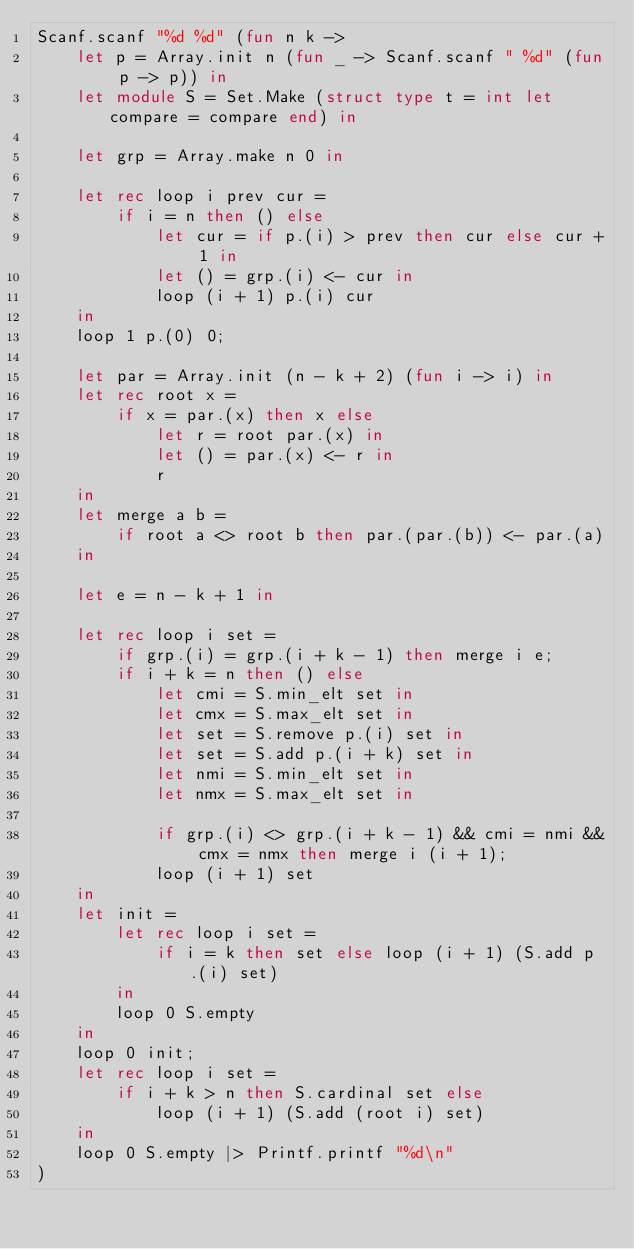Convert code to text. <code><loc_0><loc_0><loc_500><loc_500><_OCaml_>Scanf.scanf "%d %d" (fun n k ->
    let p = Array.init n (fun _ -> Scanf.scanf " %d" (fun p -> p)) in
    let module S = Set.Make (struct type t = int let compare = compare end) in

    let grp = Array.make n 0 in

    let rec loop i prev cur =
        if i = n then () else
            let cur = if p.(i) > prev then cur else cur + 1 in
            let () = grp.(i) <- cur in
            loop (i + 1) p.(i) cur
    in
    loop 1 p.(0) 0;

    let par = Array.init (n - k + 2) (fun i -> i) in
    let rec root x =
        if x = par.(x) then x else
            let r = root par.(x) in
            let () = par.(x) <- r in
            r
    in
    let merge a b =
        if root a <> root b then par.(par.(b)) <- par.(a)
    in

    let e = n - k + 1 in

    let rec loop i set =
        if grp.(i) = grp.(i + k - 1) then merge i e;
        if i + k = n then () else
            let cmi = S.min_elt set in
            let cmx = S.max_elt set in
            let set = S.remove p.(i) set in
            let set = S.add p.(i + k) set in
            let nmi = S.min_elt set in
            let nmx = S.max_elt set in

            if grp.(i) <> grp.(i + k - 1) && cmi = nmi && cmx = nmx then merge i (i + 1);
            loop (i + 1) set
    in
    let init =
        let rec loop i set =
            if i = k then set else loop (i + 1) (S.add p.(i) set)
        in
        loop 0 S.empty
    in
    loop 0 init;
    let rec loop i set =
        if i + k > n then S.cardinal set else
            loop (i + 1) (S.add (root i) set)
    in
    loop 0 S.empty |> Printf.printf "%d\n"
)</code> 